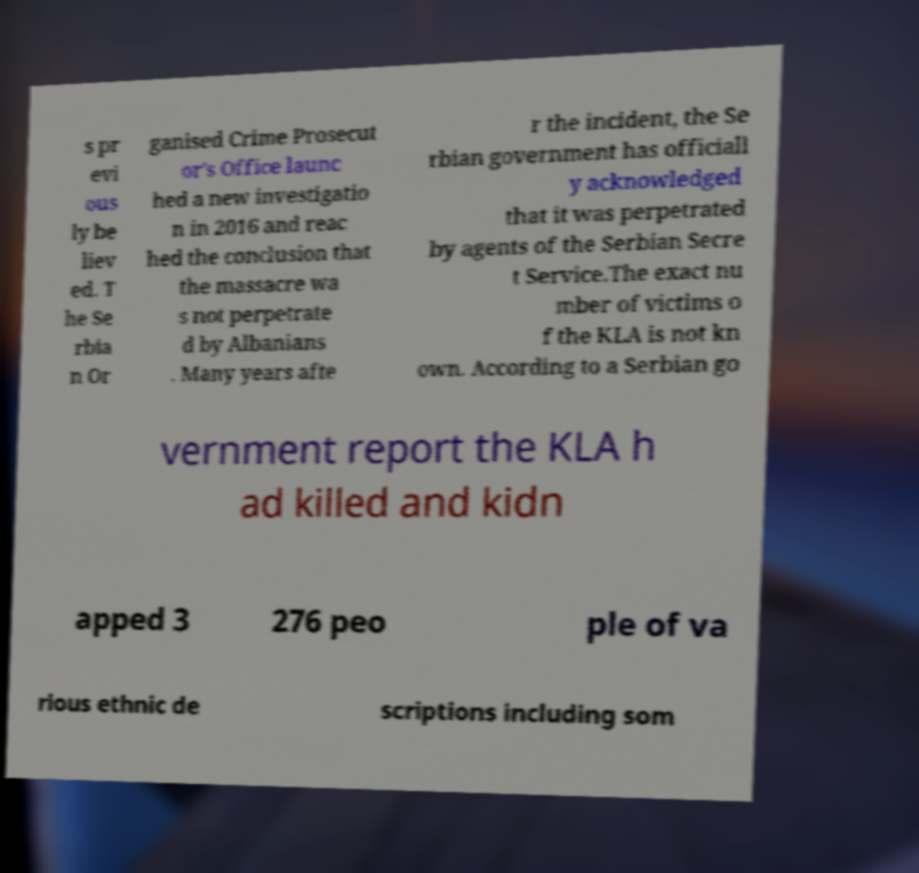I need the written content from this picture converted into text. Can you do that? s pr evi ous ly be liev ed. T he Se rbia n Or ganised Crime Prosecut or's Office launc hed a new investigatio n in 2016 and reac hed the conclusion that the massacre wa s not perpetrate d by Albanians . Many years afte r the incident, the Se rbian government has officiall y acknowledged that it was perpetrated by agents of the Serbian Secre t Service.The exact nu mber of victims o f the KLA is not kn own. According to a Serbian go vernment report the KLA h ad killed and kidn apped 3 276 peo ple of va rious ethnic de scriptions including som 